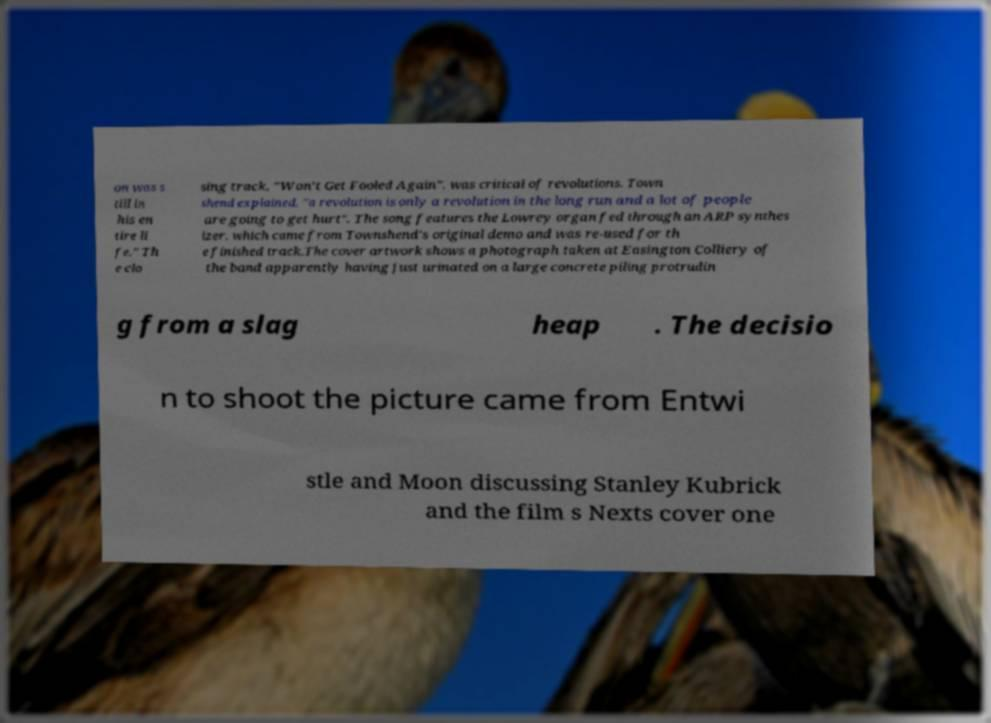Could you extract and type out the text from this image? on was s till in his en tire li fe." Th e clo sing track, "Won't Get Fooled Again", was critical of revolutions. Town shend explained, "a revolution is only a revolution in the long run and a lot of people are going to get hurt". The song features the Lowrey organ fed through an ARP synthes izer, which came from Townshend's original demo and was re-used for th e finished track.The cover artwork shows a photograph taken at Easington Colliery of the band apparently having just urinated on a large concrete piling protrudin g from a slag heap . The decisio n to shoot the picture came from Entwi stle and Moon discussing Stanley Kubrick and the film s Nexts cover one 